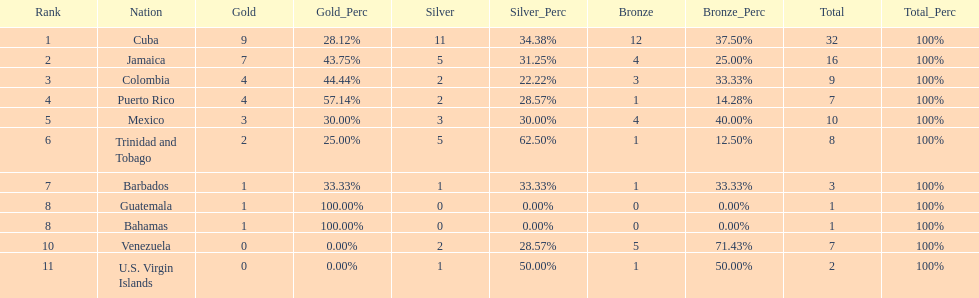Which country was awarded more than 5 silver medals? Cuba. 